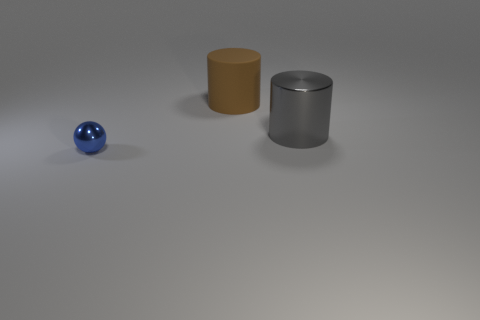Are there any other things that are the same size as the sphere?
Provide a succinct answer. No. Is there any other thing that has the same shape as the blue shiny thing?
Ensure brevity in your answer.  No. There is a thing to the right of the big brown cylinder; what is it made of?
Your response must be concise. Metal. How many other gray things are the same shape as the rubber object?
Keep it short and to the point. 1. Does the tiny metallic sphere have the same color as the rubber thing?
Offer a very short reply. No. What material is the large cylinder that is behind the shiny thing that is behind the shiny object that is in front of the large gray metallic object?
Your response must be concise. Rubber. Are there any large things in front of the large metallic object?
Keep it short and to the point. No. There is a gray metal object that is the same size as the brown cylinder; what shape is it?
Ensure brevity in your answer.  Cylinder. Are the gray object and the tiny object made of the same material?
Give a very brief answer. Yes. What number of rubber things are large gray balls or small blue spheres?
Make the answer very short. 0. 